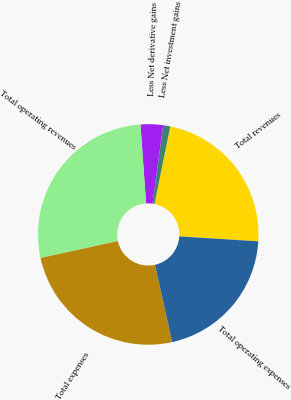<chart> <loc_0><loc_0><loc_500><loc_500><pie_chart><fcel>Total revenues<fcel>Less Net investment gains<fcel>Less Net derivative gains<fcel>Total operating revenues<fcel>Total expenses<fcel>Total operating expenses<nl><fcel>22.79%<fcel>1.04%<fcel>3.29%<fcel>27.3%<fcel>25.05%<fcel>20.53%<nl></chart> 